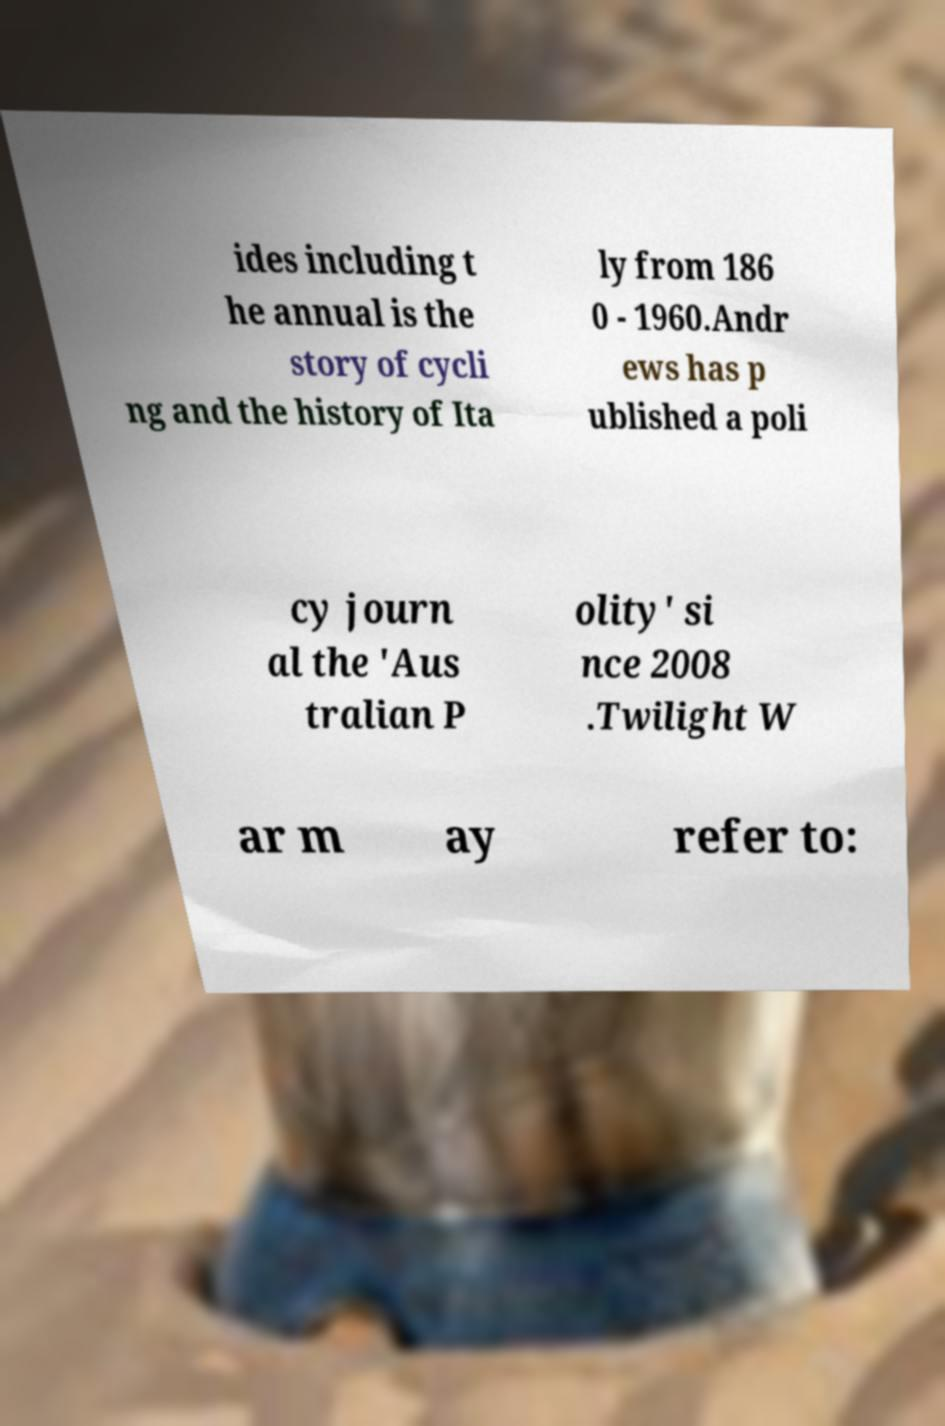Please read and relay the text visible in this image. What does it say? ides including t he annual is the story of cycli ng and the history of Ita ly from 186 0 - 1960.Andr ews has p ublished a poli cy journ al the 'Aus tralian P olity' si nce 2008 .Twilight W ar m ay refer to: 